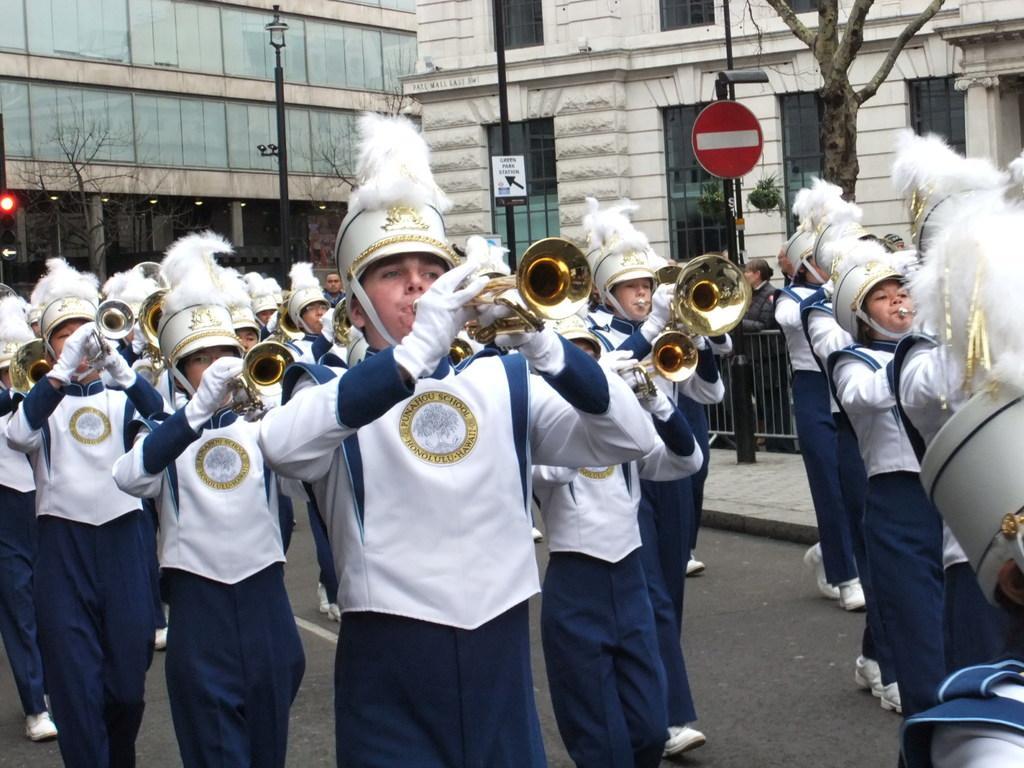Please provide a concise description of this image. As we can see in the image there are group of people playing musical instruments. There are buildings, street lamps and trees. 